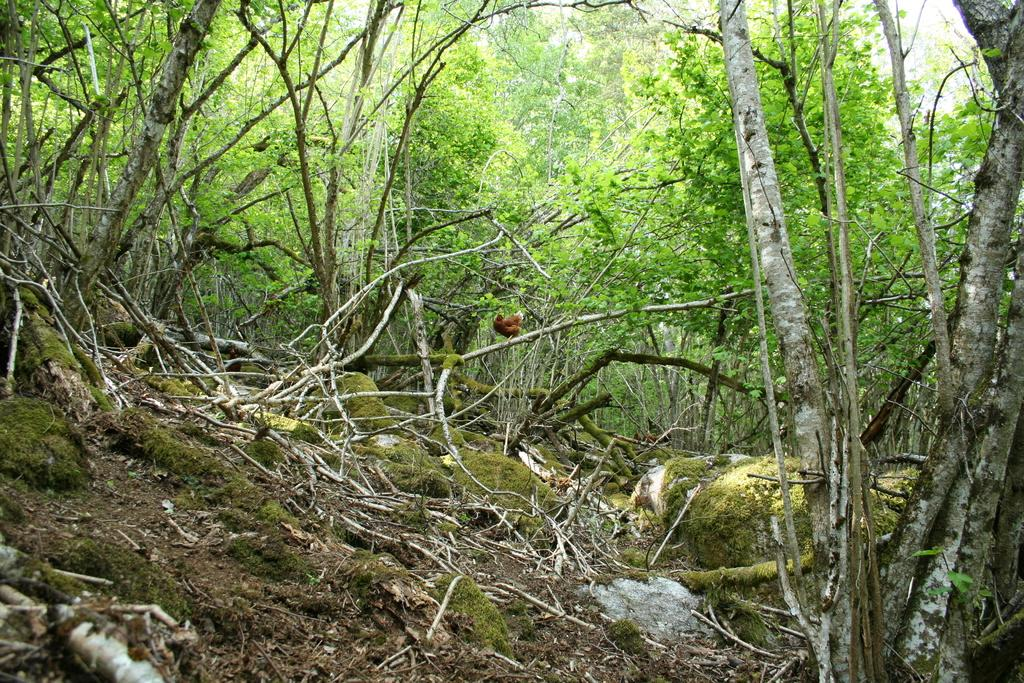What type of vegetation can be seen in the image? There are trees in the image. What other objects related to trees can be seen in the image? There are twigs in the image. How does the image show the territory of the lock in the area? There is no mention of a lock or territory in the image; it only features trees and twigs. 